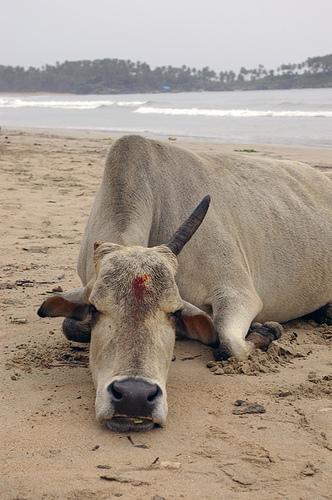What is the cow laying on?
Be succinct. Sand. How many horns does the cow have?
Quick response, please. 1. Is the cow on a beach?
Be succinct. Yes. 